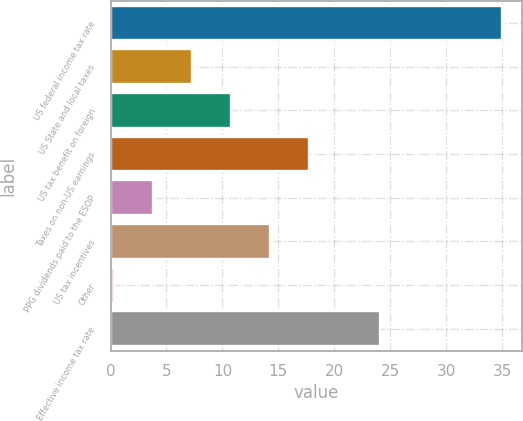<chart> <loc_0><loc_0><loc_500><loc_500><bar_chart><fcel>US federal income tax rate<fcel>US State and local taxes<fcel>US tax benefit on foreign<fcel>Taxes on non-US earnings<fcel>PPG dividends paid to the ESOP<fcel>US tax incentives<fcel>Other<fcel>Effective income tax rate<nl><fcel>35<fcel>7.28<fcel>10.75<fcel>17.69<fcel>3.81<fcel>14.22<fcel>0.34<fcel>24.11<nl></chart> 